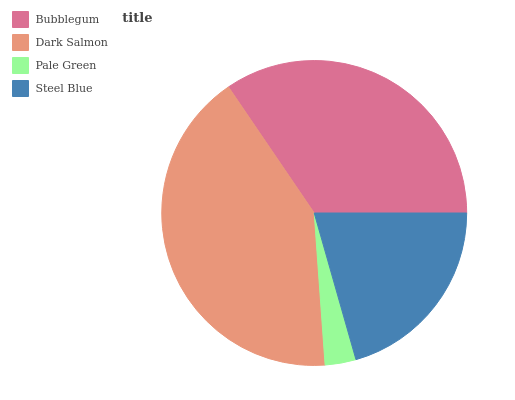Is Pale Green the minimum?
Answer yes or no. Yes. Is Dark Salmon the maximum?
Answer yes or no. Yes. Is Dark Salmon the minimum?
Answer yes or no. No. Is Pale Green the maximum?
Answer yes or no. No. Is Dark Salmon greater than Pale Green?
Answer yes or no. Yes. Is Pale Green less than Dark Salmon?
Answer yes or no. Yes. Is Pale Green greater than Dark Salmon?
Answer yes or no. No. Is Dark Salmon less than Pale Green?
Answer yes or no. No. Is Bubblegum the high median?
Answer yes or no. Yes. Is Steel Blue the low median?
Answer yes or no. Yes. Is Dark Salmon the high median?
Answer yes or no. No. Is Dark Salmon the low median?
Answer yes or no. No. 